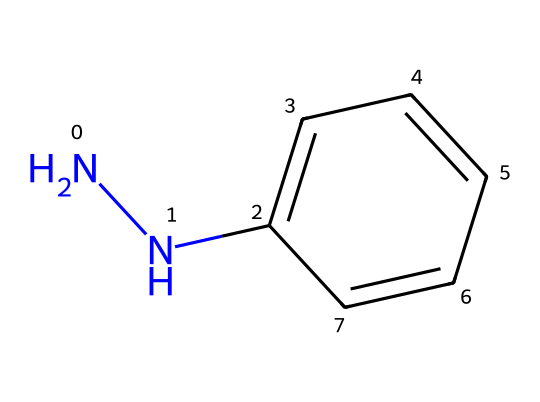What is the number of nitrogen atoms in this molecule? The SMILES representation shows "NN," indicating two nitrogen atoms present in the structure.
Answer: 2 What is the molecular formula of this compound? By analyzing the SMILES, there are two nitrogen (N) atoms and six carbon (C) atoms, along with an implied number of hydrogen (H) atoms to satisfy the valence. The formula is C6H8N2.
Answer: C6H8N2 How many aromatic rings are present in this structure? The presence of "c" in the SMILES indicates aromatic carbon atoms; thus, we can see there is one complete aromatic ring represented by "c1ccccc1."
Answer: 1 What is the hybridization of the nitrogen atoms in this compound? The nitrogen atoms in hydrazine are typically sp2 hybridized because they bond to carbon and exhibit a trigonal planar arrangement around each nitrogen.
Answer: sp2 Which functional group is primarily present in this compound? The structure contains nitrogen atoms that are bonded with carbon, fitting the definition of a hydrazine as it features a -N-N- bond within its chemical structure.
Answer: hydrazine What is the primary chemical family of this substance? The presence of the nitrogen-nitrogen bond and its related characteristics classifies this compound as part of the hydrazine family.
Answer: hydrazines What historical significance does this compound have in photography? Hydrazines have been utilized in photographic paper manufacturing as reducing agents, significant in early photographic processes.
Answer: reducing agents 